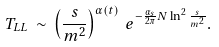Convert formula to latex. <formula><loc_0><loc_0><loc_500><loc_500>T _ { L L } \, \sim \, \left ( \frac { s } { m ^ { 2 } } \right ) ^ { \alpha ( t ) } \, e ^ { - \frac { \alpha _ { s } } { 2 \pi } N \ln ^ { 2 } \frac { s } { m ^ { 2 } } } .</formula> 